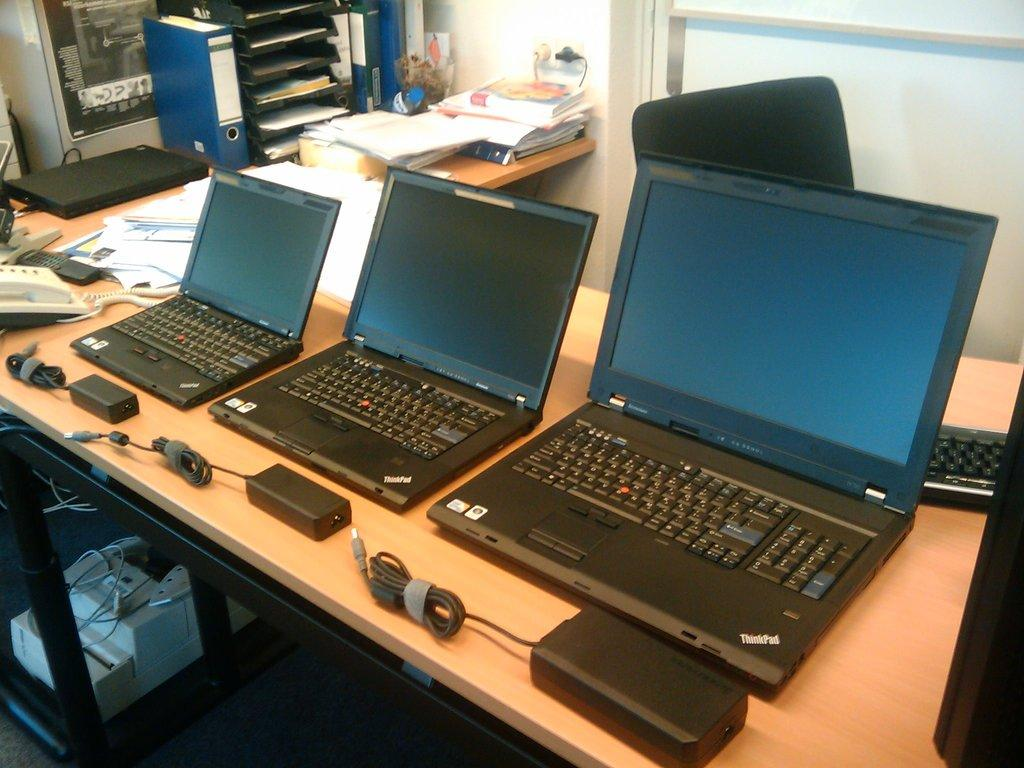<image>
Write a terse but informative summary of the picture. Three black laptops that have Thinkpad wrote on the bottom right 